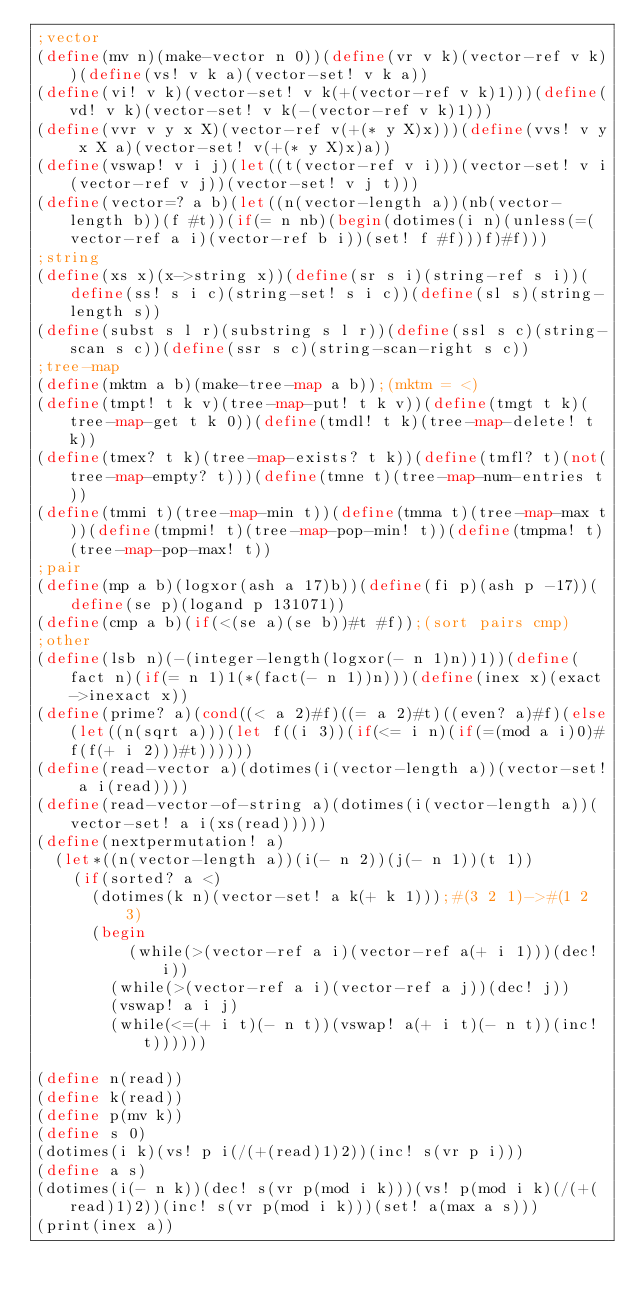<code> <loc_0><loc_0><loc_500><loc_500><_Scheme_>;vector
(define(mv n)(make-vector n 0))(define(vr v k)(vector-ref v k))(define(vs! v k a)(vector-set! v k a))
(define(vi! v k)(vector-set! v k(+(vector-ref v k)1)))(define(vd! v k)(vector-set! v k(-(vector-ref v k)1)))
(define(vvr v y x X)(vector-ref v(+(* y X)x)))(define(vvs! v y x X a)(vector-set! v(+(* y X)x)a))
(define(vswap! v i j)(let((t(vector-ref v i)))(vector-set! v i(vector-ref v j))(vector-set! v j t)))
(define(vector=? a b)(let((n(vector-length a))(nb(vector-length b))(f #t))(if(= n nb)(begin(dotimes(i n)(unless(=(vector-ref a i)(vector-ref b i))(set! f #f)))f)#f)))
;string
(define(xs x)(x->string x))(define(sr s i)(string-ref s i))(define(ss! s i c)(string-set! s i c))(define(sl s)(string-length s))
(define(subst s l r)(substring s l r))(define(ssl s c)(string-scan s c))(define(ssr s c)(string-scan-right s c))
;tree-map
(define(mktm a b)(make-tree-map a b));(mktm = <)
(define(tmpt! t k v)(tree-map-put! t k v))(define(tmgt t k)(tree-map-get t k 0))(define(tmdl! t k)(tree-map-delete! t k))
(define(tmex? t k)(tree-map-exists? t k))(define(tmfl? t)(not(tree-map-empty? t)))(define(tmne t)(tree-map-num-entries t))
(define(tmmi t)(tree-map-min t))(define(tmma t)(tree-map-max t))(define(tmpmi! t)(tree-map-pop-min! t))(define(tmpma! t)(tree-map-pop-max! t))
;pair
(define(mp a b)(logxor(ash a 17)b))(define(fi p)(ash p -17))(define(se p)(logand p 131071))
(define(cmp a b)(if(<(se a)(se b))#t #f));(sort pairs cmp)
;other
(define(lsb n)(-(integer-length(logxor(- n 1)n))1))(define(fact n)(if(= n 1)1(*(fact(- n 1))n)))(define(inex x)(exact->inexact x))
(define(prime? a)(cond((< a 2)#f)((= a 2)#t)((even? a)#f)(else(let((n(sqrt a)))(let f((i 3))(if(<= i n)(if(=(mod a i)0)#f(f(+ i 2)))#t))))))
(define(read-vector a)(dotimes(i(vector-length a))(vector-set! a i(read))))
(define(read-vector-of-string a)(dotimes(i(vector-length a))(vector-set! a i(xs(read)))))
(define(nextpermutation! a)
	(let*((n(vector-length a))(i(- n 2))(j(- n 1))(t 1))
		(if(sorted? a <)
			(dotimes(k n)(vector-set! a k(+ k 1)));#(3 2 1)->#(1 2 3)
			(begin
	  			(while(>(vector-ref a i)(vector-ref a(+ i 1)))(dec! i))
				(while(>(vector-ref a i)(vector-ref a j))(dec! j))
				(vswap! a i j)
				(while(<=(+ i t)(- n t))(vswap! a(+ i t)(- n t))(inc! t))))))

(define n(read))
(define k(read))
(define p(mv k))
(define s 0)
(dotimes(i k)(vs! p i(/(+(read)1)2))(inc! s(vr p i)))
(define a s)
(dotimes(i(- n k))(dec! s(vr p(mod i k)))(vs! p(mod i k)(/(+(read)1)2))(inc! s(vr p(mod i k)))(set! a(max a s)))
(print(inex a))
</code> 